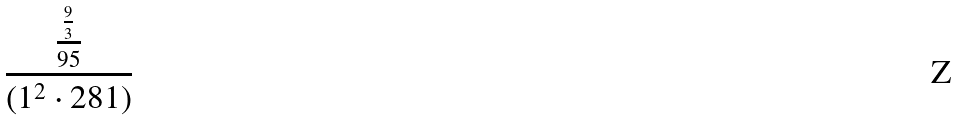<formula> <loc_0><loc_0><loc_500><loc_500>\frac { \frac { \frac { 9 } { 3 } } { 9 5 } } { ( 1 ^ { 2 } \cdot 2 8 1 ) }</formula> 